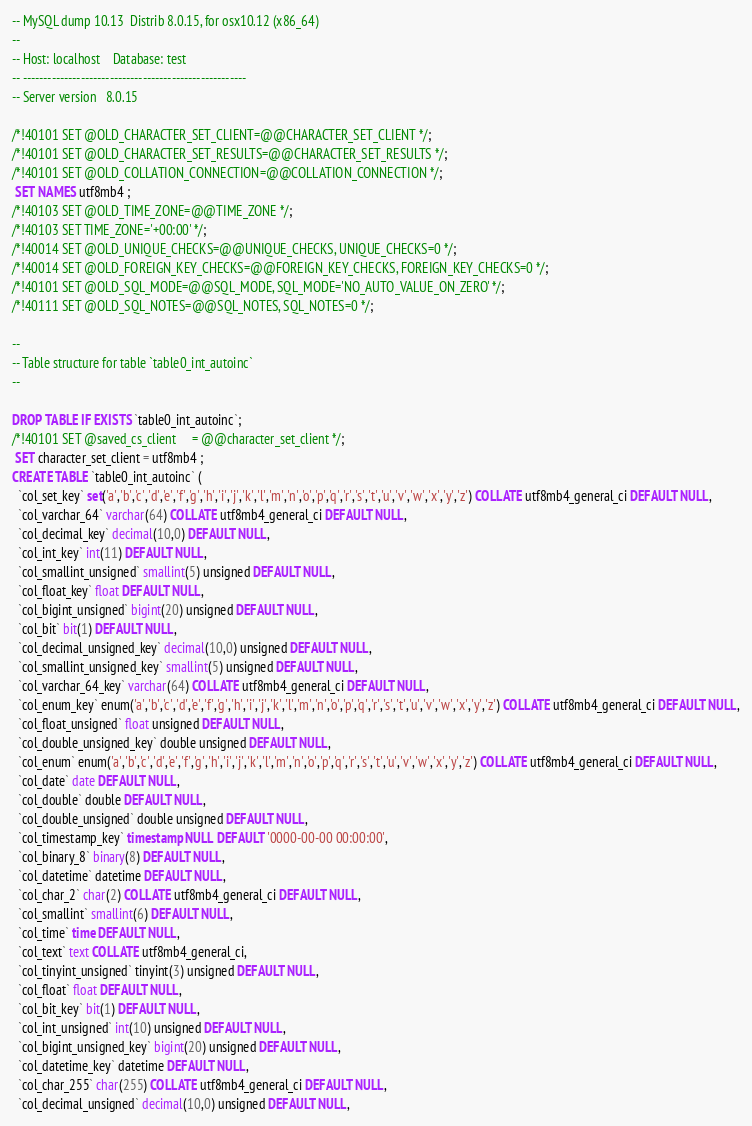<code> <loc_0><loc_0><loc_500><loc_500><_SQL_>-- MySQL dump 10.13  Distrib 8.0.15, for osx10.12 (x86_64)
--
-- Host: localhost    Database: test
-- ------------------------------------------------------
-- Server version	8.0.15

/*!40101 SET @OLD_CHARACTER_SET_CLIENT=@@CHARACTER_SET_CLIENT */;
/*!40101 SET @OLD_CHARACTER_SET_RESULTS=@@CHARACTER_SET_RESULTS */;
/*!40101 SET @OLD_COLLATION_CONNECTION=@@COLLATION_CONNECTION */;
 SET NAMES utf8mb4 ;
/*!40103 SET @OLD_TIME_ZONE=@@TIME_ZONE */;
/*!40103 SET TIME_ZONE='+00:00' */;
/*!40014 SET @OLD_UNIQUE_CHECKS=@@UNIQUE_CHECKS, UNIQUE_CHECKS=0 */;
/*!40014 SET @OLD_FOREIGN_KEY_CHECKS=@@FOREIGN_KEY_CHECKS, FOREIGN_KEY_CHECKS=0 */;
/*!40101 SET @OLD_SQL_MODE=@@SQL_MODE, SQL_MODE='NO_AUTO_VALUE_ON_ZERO' */;
/*!40111 SET @OLD_SQL_NOTES=@@SQL_NOTES, SQL_NOTES=0 */;

--
-- Table structure for table `table0_int_autoinc`
--

DROP TABLE IF EXISTS `table0_int_autoinc`;
/*!40101 SET @saved_cs_client     = @@character_set_client */;
 SET character_set_client = utf8mb4 ;
CREATE TABLE `table0_int_autoinc` (
  `col_set_key` set('a','b','c','d','e','f','g','h','i','j','k','l','m','n','o','p','q','r','s','t','u','v','w','x','y','z') COLLATE utf8mb4_general_ci DEFAULT NULL,
  `col_varchar_64` varchar(64) COLLATE utf8mb4_general_ci DEFAULT NULL,
  `col_decimal_key` decimal(10,0) DEFAULT NULL,
  `col_int_key` int(11) DEFAULT NULL,
  `col_smallint_unsigned` smallint(5) unsigned DEFAULT NULL,
  `col_float_key` float DEFAULT NULL,
  `col_bigint_unsigned` bigint(20) unsigned DEFAULT NULL,
  `col_bit` bit(1) DEFAULT NULL,
  `col_decimal_unsigned_key` decimal(10,0) unsigned DEFAULT NULL,
  `col_smallint_unsigned_key` smallint(5) unsigned DEFAULT NULL,
  `col_varchar_64_key` varchar(64) COLLATE utf8mb4_general_ci DEFAULT NULL,
  `col_enum_key` enum('a','b','c','d','e','f','g','h','i','j','k','l','m','n','o','p','q','r','s','t','u','v','w','x','y','z') COLLATE utf8mb4_general_ci DEFAULT NULL,
  `col_float_unsigned` float unsigned DEFAULT NULL,
  `col_double_unsigned_key` double unsigned DEFAULT NULL,
  `col_enum` enum('a','b','c','d','e','f','g','h','i','j','k','l','m','n','o','p','q','r','s','t','u','v','w','x','y','z') COLLATE utf8mb4_general_ci DEFAULT NULL,
  `col_date` date DEFAULT NULL,
  `col_double` double DEFAULT NULL,
  `col_double_unsigned` double unsigned DEFAULT NULL,
  `col_timestamp_key` timestamp NULL DEFAULT '0000-00-00 00:00:00',
  `col_binary_8` binary(8) DEFAULT NULL,
  `col_datetime` datetime DEFAULT NULL,
  `col_char_2` char(2) COLLATE utf8mb4_general_ci DEFAULT NULL,
  `col_smallint` smallint(6) DEFAULT NULL,
  `col_time` time DEFAULT NULL,
  `col_text` text COLLATE utf8mb4_general_ci,
  `col_tinyint_unsigned` tinyint(3) unsigned DEFAULT NULL,
  `col_float` float DEFAULT NULL,
  `col_bit_key` bit(1) DEFAULT NULL,
  `col_int_unsigned` int(10) unsigned DEFAULT NULL,
  `col_bigint_unsigned_key` bigint(20) unsigned DEFAULT NULL,
  `col_datetime_key` datetime DEFAULT NULL,
  `col_char_255` char(255) COLLATE utf8mb4_general_ci DEFAULT NULL,
  `col_decimal_unsigned` decimal(10,0) unsigned DEFAULT NULL,</code> 